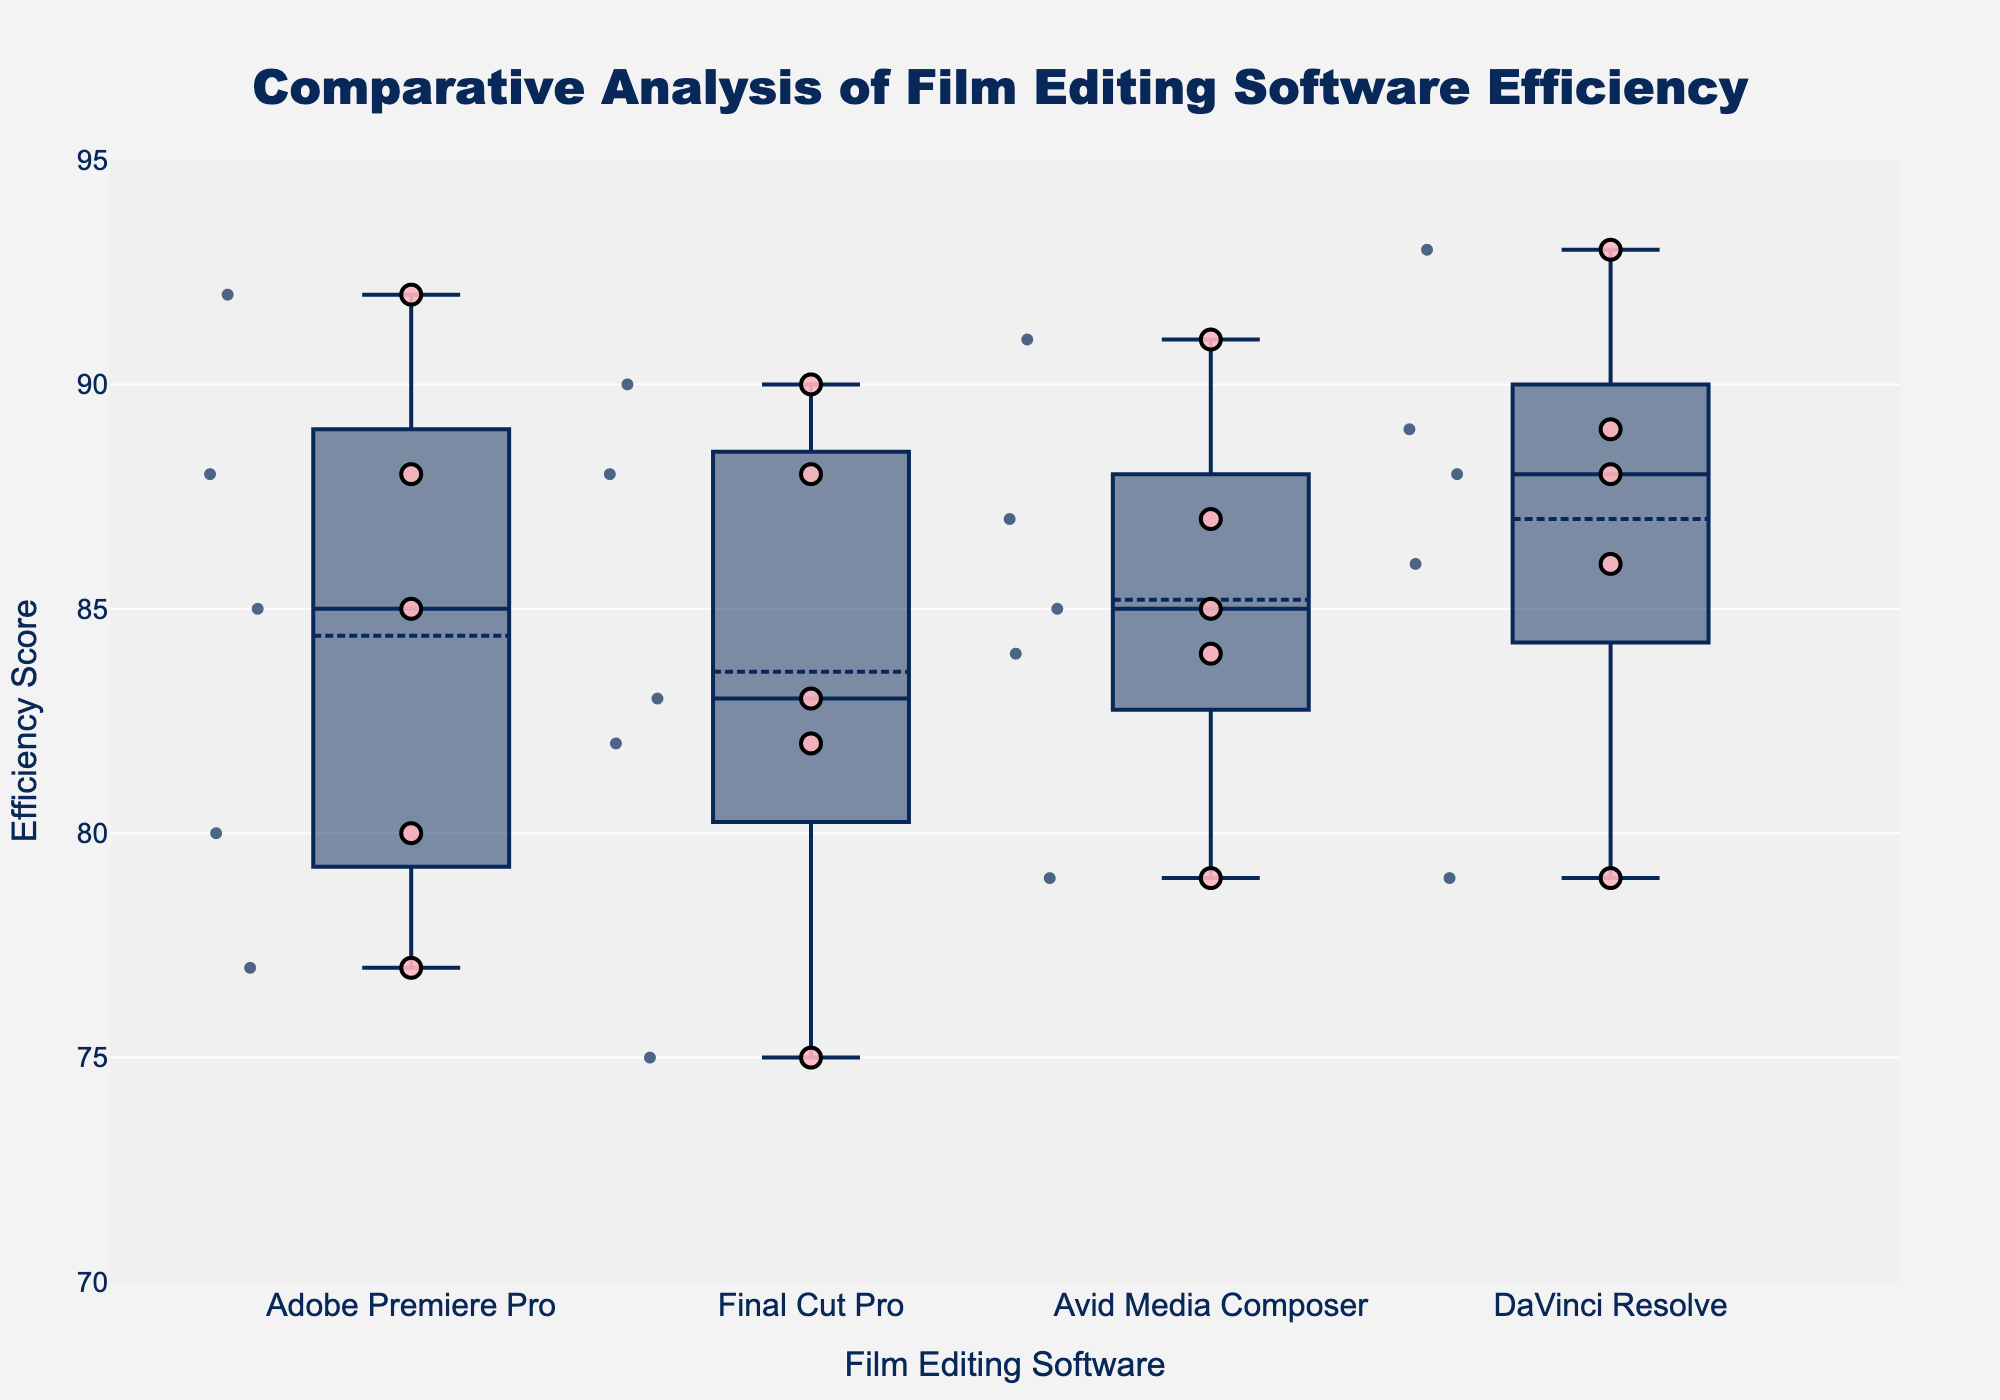What's the title of the figure? The title is displayed at the top of the figure and is positioned in the center, making it easy to identify.
Answer: Comparative Analysis of Film Editing Software Efficiency What is the y-axis title? The y-axis title is indicated to the left side of the y-axis.
Answer: Efficiency Score Which editing software has the highest median efficiency score? The median for each software is represented by the horizontal line within each box. By comparing these lines, Avid Media Composer has the highest median.
Answer: Avid Media Composer How many individual editors' efficiency scores are shown for DaVinci Resolve? Each scatter point represents an individual editor's efficiency score. Counting these points for DaVinci Resolve results in 5.
Answer: 5 What's the range of efficiency scores for Adobe Premiere Pro? The range is determined by the minimum and maximum points within the box plot, excluding any outliers. Adobe Premiere Pro ranges from 77 to 92.
Answer: 77 to 92 Which software has the greatest spread in efficiency scores? The spread can be determined by the length of the box and the whiskers. Final Cut Pro has the greatest spread as indicated by a wide box and long whiskers.
Answer: Final Cut Pro Are there any outliers in the data? Outliers are indicated by points outside the whiskers of a box plot. There are no outliers presented in any of the software groups.
Answer: No Which editor has the highest individual efficiency score and which software does this editor use? By examining the highest scatter points, Henry Adams with DaVinci Resolve has the highest score of 93.
Answer: Henry Adams, DaVinci Resolve What is the interquartile range (IQR) of the efficiency scores for Final Cut Pro? IQR is the difference between the first quartile (Q1) and third quartile (Q3). For Final Cut Pro, Q1 is around 80 and Q3 is around 88, making the IQR 88-80.
Answer: 8 Which software has the lowest minimum efficiency score? The minimum is the smallest value in the whiskers of the box plot. Final Cut Pro has the lowest minimum at 75.
Answer: Final Cut Pro 